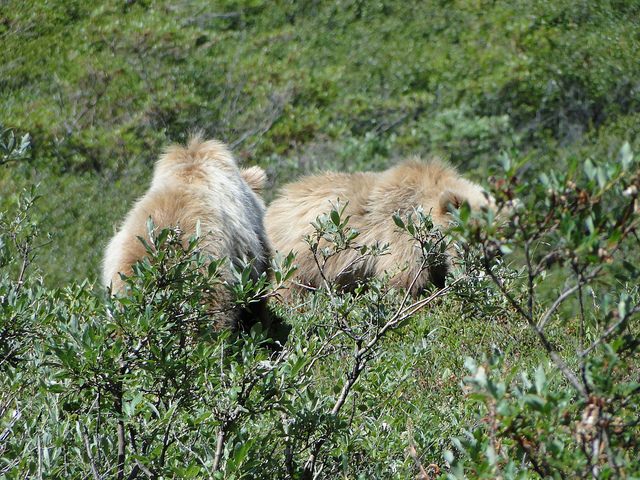Are these animals typically found in this kind of environment? Yes, the animals in the photo resemble species that thrive in brush and forest areas, as these environments provide ample food and cover. 